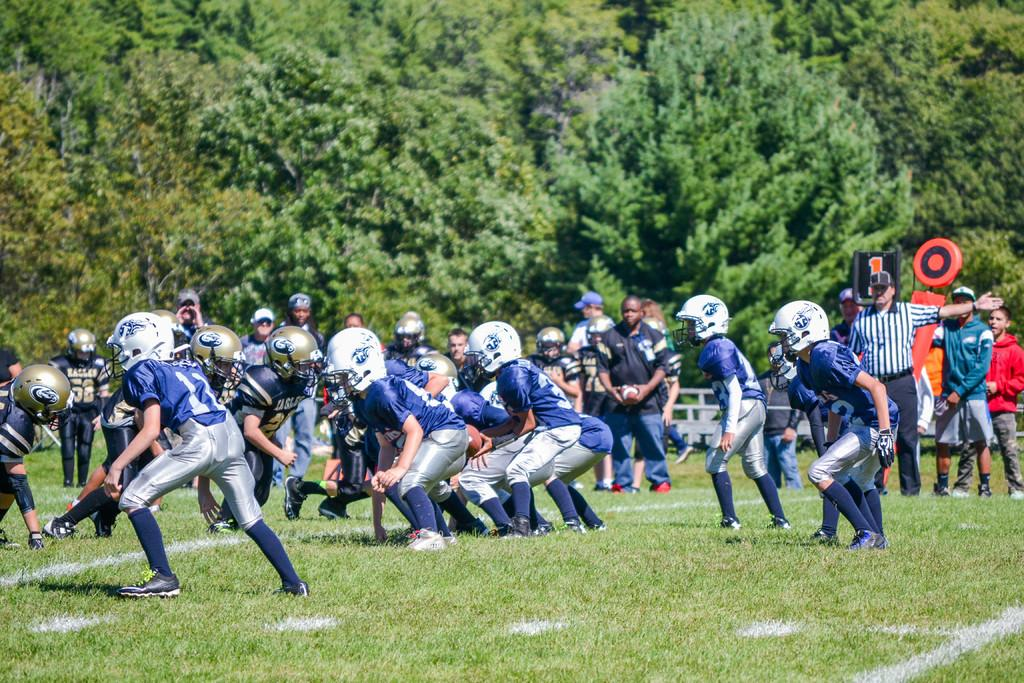What is happening in the image involving the group of people? The people are playing a game in the image. What can be seen in the background of the image? There are objects and trees in the background of the image. What is the temperature of the disgust in the image? There is no mention of disgust or temperature in the image; it features a group of people playing a game with objects and trees in the background. 